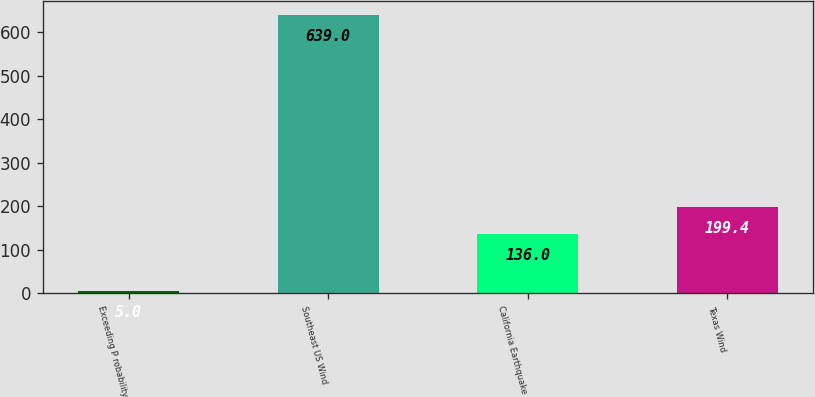<chart> <loc_0><loc_0><loc_500><loc_500><bar_chart><fcel>Exceeding P robability<fcel>Southeast US Wind<fcel>California Earthquake<fcel>Texas Wind<nl><fcel>5<fcel>639<fcel>136<fcel>199.4<nl></chart> 